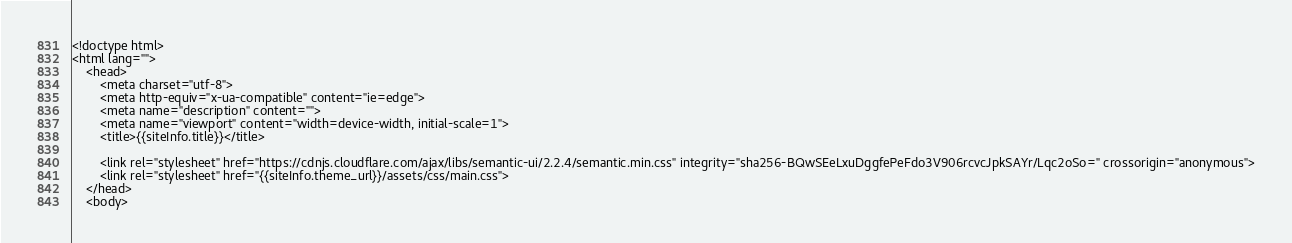<code> <loc_0><loc_0><loc_500><loc_500><_PHP_><!doctype html>
<html lang="">
    <head>
        <meta charset="utf-8">
        <meta http-equiv="x-ua-compatible" content="ie=edge">
        <meta name="description" content="">
        <meta name="viewport" content="width=device-width, initial-scale=1">
        <title>{{siteInfo.title}}</title>

        <link rel="stylesheet" href="https://cdnjs.cloudflare.com/ajax/libs/semantic-ui/2.2.4/semantic.min.css" integrity="sha256-BQwSEeLxuDggfePeFdo3V906rcvcJpkSAYr/Lqc2oSo=" crossorigin="anonymous">
        <link rel="stylesheet" href="{{siteInfo.theme_url}}/assets/css/main.css">
    </head>
    <body>
</code> 